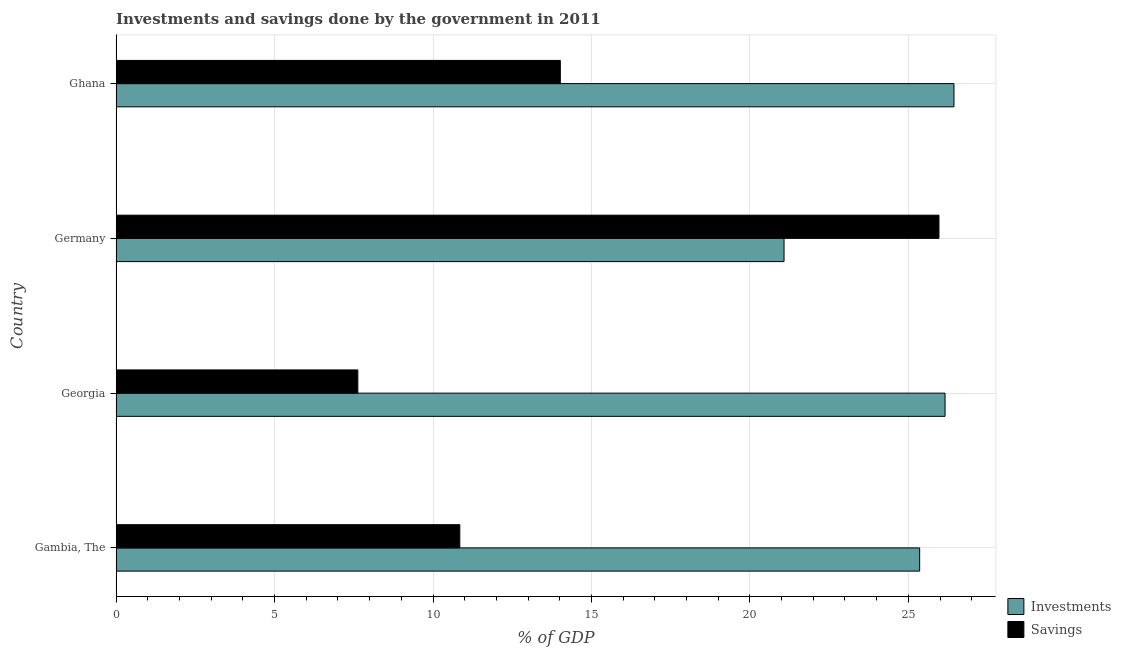How many different coloured bars are there?
Provide a short and direct response. 2. Are the number of bars on each tick of the Y-axis equal?
Your answer should be compact. Yes. What is the label of the 4th group of bars from the top?
Your answer should be compact. Gambia, The. What is the savings of government in Gambia, The?
Keep it short and to the point. 10.85. Across all countries, what is the maximum savings of government?
Provide a short and direct response. 25.97. Across all countries, what is the minimum investments of government?
Offer a terse response. 21.08. In which country was the investments of government minimum?
Make the answer very short. Germany. What is the total savings of government in the graph?
Provide a short and direct response. 58.46. What is the difference between the investments of government in Georgia and that in Germany?
Ensure brevity in your answer.  5.08. What is the difference between the investments of government in Ghana and the savings of government in Gambia, The?
Your answer should be compact. 15.59. What is the average savings of government per country?
Your response must be concise. 14.61. What is the difference between the investments of government and savings of government in Georgia?
Keep it short and to the point. 18.53. In how many countries, is the investments of government greater than 9 %?
Keep it short and to the point. 4. What is the ratio of the investments of government in Germany to that in Ghana?
Keep it short and to the point. 0.8. Is the savings of government in Gambia, The less than that in Germany?
Ensure brevity in your answer.  Yes. What is the difference between the highest and the second highest investments of government?
Provide a short and direct response. 0.28. What is the difference between the highest and the lowest savings of government?
Your response must be concise. 18.34. In how many countries, is the savings of government greater than the average savings of government taken over all countries?
Ensure brevity in your answer.  1. What does the 2nd bar from the top in Ghana represents?
Provide a succinct answer. Investments. What does the 1st bar from the bottom in Georgia represents?
Your response must be concise. Investments. Are all the bars in the graph horizontal?
Provide a short and direct response. Yes. How many countries are there in the graph?
Provide a short and direct response. 4. Does the graph contain any zero values?
Keep it short and to the point. No. Where does the legend appear in the graph?
Your answer should be compact. Bottom right. How are the legend labels stacked?
Offer a very short reply. Vertical. What is the title of the graph?
Provide a short and direct response. Investments and savings done by the government in 2011. What is the label or title of the X-axis?
Offer a terse response. % of GDP. What is the label or title of the Y-axis?
Give a very brief answer. Country. What is the % of GDP in Investments in Gambia, The?
Provide a short and direct response. 25.36. What is the % of GDP in Savings in Gambia, The?
Ensure brevity in your answer.  10.85. What is the % of GDP in Investments in Georgia?
Your response must be concise. 26.16. What is the % of GDP of Savings in Georgia?
Offer a very short reply. 7.63. What is the % of GDP in Investments in Germany?
Offer a very short reply. 21.08. What is the % of GDP of Savings in Germany?
Offer a very short reply. 25.97. What is the % of GDP of Investments in Ghana?
Your response must be concise. 26.44. What is the % of GDP of Savings in Ghana?
Offer a terse response. 14.02. Across all countries, what is the maximum % of GDP of Investments?
Provide a succinct answer. 26.44. Across all countries, what is the maximum % of GDP in Savings?
Provide a succinct answer. 25.97. Across all countries, what is the minimum % of GDP in Investments?
Offer a very short reply. 21.08. Across all countries, what is the minimum % of GDP in Savings?
Your answer should be very brief. 7.63. What is the total % of GDP in Investments in the graph?
Provide a short and direct response. 99.03. What is the total % of GDP of Savings in the graph?
Your answer should be compact. 58.46. What is the difference between the % of GDP in Investments in Gambia, The and that in Georgia?
Ensure brevity in your answer.  -0.8. What is the difference between the % of GDP in Savings in Gambia, The and that in Georgia?
Offer a very short reply. 3.22. What is the difference between the % of GDP in Investments in Gambia, The and that in Germany?
Offer a terse response. 4.28. What is the difference between the % of GDP in Savings in Gambia, The and that in Germany?
Ensure brevity in your answer.  -15.12. What is the difference between the % of GDP of Investments in Gambia, The and that in Ghana?
Provide a short and direct response. -1.08. What is the difference between the % of GDP of Savings in Gambia, The and that in Ghana?
Provide a succinct answer. -3.17. What is the difference between the % of GDP in Investments in Georgia and that in Germany?
Provide a succinct answer. 5.08. What is the difference between the % of GDP of Savings in Georgia and that in Germany?
Keep it short and to the point. -18.34. What is the difference between the % of GDP of Investments in Georgia and that in Ghana?
Provide a succinct answer. -0.28. What is the difference between the % of GDP of Savings in Georgia and that in Ghana?
Provide a succinct answer. -6.39. What is the difference between the % of GDP in Investments in Germany and that in Ghana?
Make the answer very short. -5.36. What is the difference between the % of GDP in Savings in Germany and that in Ghana?
Ensure brevity in your answer.  11.95. What is the difference between the % of GDP in Investments in Gambia, The and the % of GDP in Savings in Georgia?
Make the answer very short. 17.73. What is the difference between the % of GDP in Investments in Gambia, The and the % of GDP in Savings in Germany?
Offer a terse response. -0.61. What is the difference between the % of GDP in Investments in Gambia, The and the % of GDP in Savings in Ghana?
Offer a terse response. 11.34. What is the difference between the % of GDP in Investments in Georgia and the % of GDP in Savings in Germany?
Your answer should be compact. 0.19. What is the difference between the % of GDP of Investments in Georgia and the % of GDP of Savings in Ghana?
Offer a very short reply. 12.14. What is the difference between the % of GDP in Investments in Germany and the % of GDP in Savings in Ghana?
Make the answer very short. 7.06. What is the average % of GDP of Investments per country?
Make the answer very short. 24.76. What is the average % of GDP in Savings per country?
Your answer should be compact. 14.61. What is the difference between the % of GDP of Investments and % of GDP of Savings in Gambia, The?
Provide a succinct answer. 14.51. What is the difference between the % of GDP of Investments and % of GDP of Savings in Georgia?
Provide a short and direct response. 18.53. What is the difference between the % of GDP in Investments and % of GDP in Savings in Germany?
Offer a terse response. -4.89. What is the difference between the % of GDP of Investments and % of GDP of Savings in Ghana?
Give a very brief answer. 12.42. What is the ratio of the % of GDP in Investments in Gambia, The to that in Georgia?
Your answer should be compact. 0.97. What is the ratio of the % of GDP in Savings in Gambia, The to that in Georgia?
Your response must be concise. 1.42. What is the ratio of the % of GDP in Investments in Gambia, The to that in Germany?
Your response must be concise. 1.2. What is the ratio of the % of GDP of Savings in Gambia, The to that in Germany?
Provide a short and direct response. 0.42. What is the ratio of the % of GDP in Savings in Gambia, The to that in Ghana?
Your answer should be compact. 0.77. What is the ratio of the % of GDP of Investments in Georgia to that in Germany?
Ensure brevity in your answer.  1.24. What is the ratio of the % of GDP in Savings in Georgia to that in Germany?
Give a very brief answer. 0.29. What is the ratio of the % of GDP in Investments in Georgia to that in Ghana?
Your answer should be compact. 0.99. What is the ratio of the % of GDP in Savings in Georgia to that in Ghana?
Your response must be concise. 0.54. What is the ratio of the % of GDP of Investments in Germany to that in Ghana?
Your response must be concise. 0.8. What is the ratio of the % of GDP in Savings in Germany to that in Ghana?
Offer a very short reply. 1.85. What is the difference between the highest and the second highest % of GDP in Investments?
Your answer should be compact. 0.28. What is the difference between the highest and the second highest % of GDP in Savings?
Provide a succinct answer. 11.95. What is the difference between the highest and the lowest % of GDP in Investments?
Offer a very short reply. 5.36. What is the difference between the highest and the lowest % of GDP in Savings?
Provide a short and direct response. 18.34. 